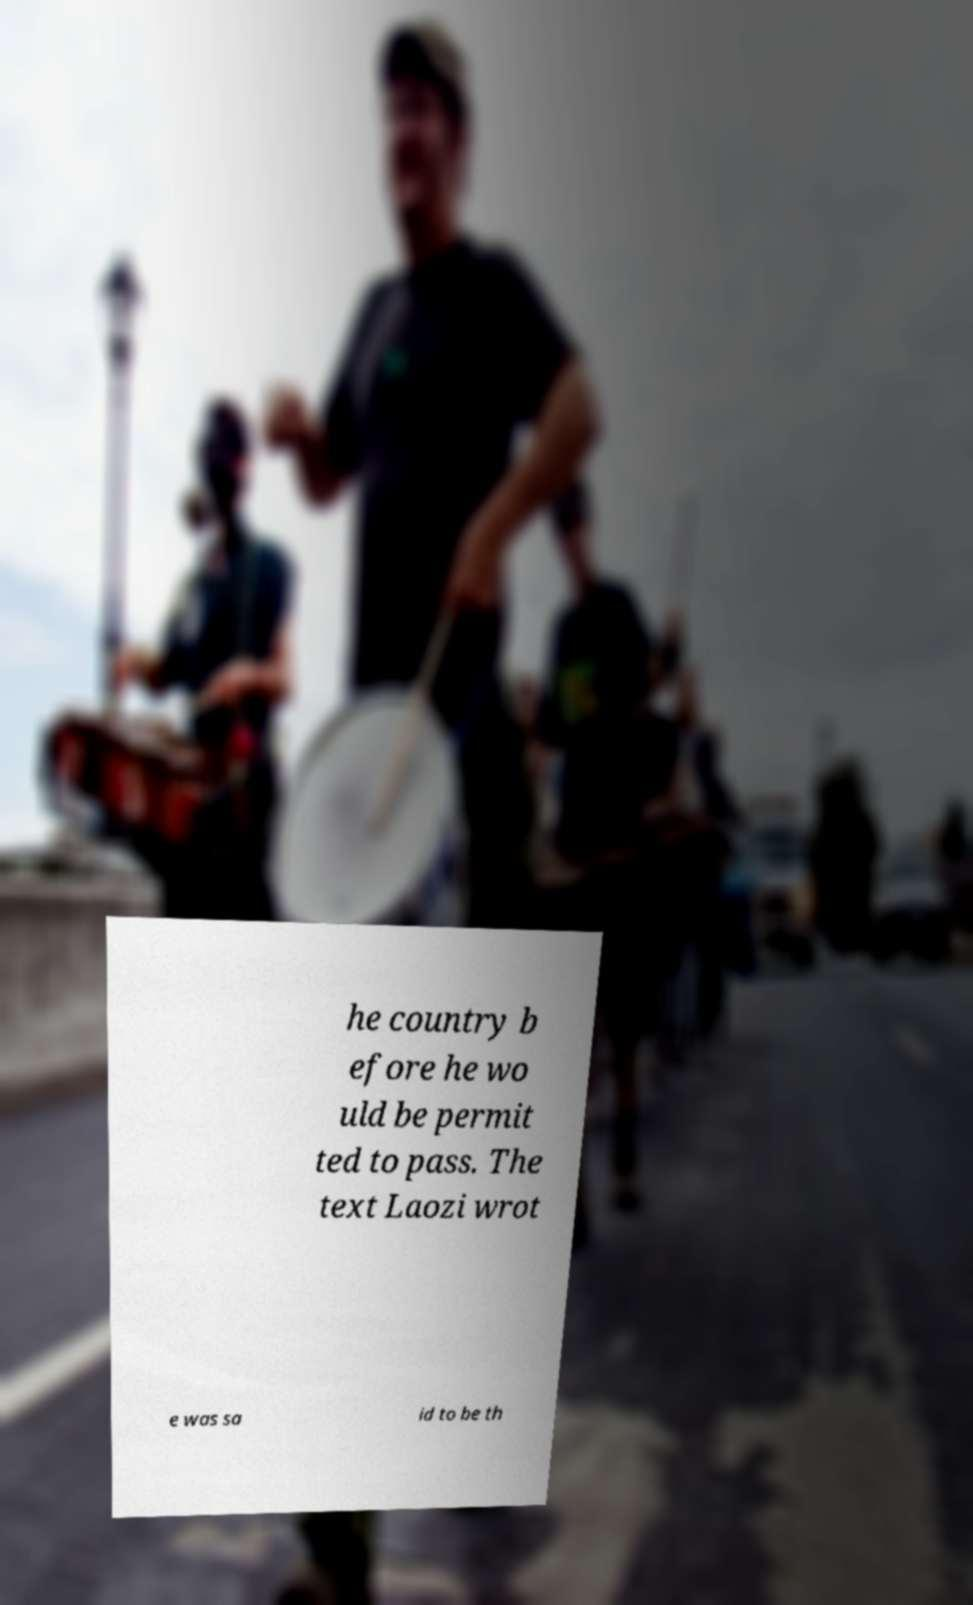I need the written content from this picture converted into text. Can you do that? he country b efore he wo uld be permit ted to pass. The text Laozi wrot e was sa id to be th 